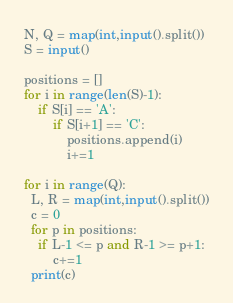<code> <loc_0><loc_0><loc_500><loc_500><_Python_>N, Q = map(int,input().split())
S = input()

positions = []
for i in range(len(S)-1):
    if S[i] == 'A':
        if S[i+1] == 'C':
            positions.append(i)
            i+=1

for i in range(Q):
  L, R = map(int,input().split())
  c = 0
  for p in positions:
    if L-1 <= p and R-1 >= p+1:
        c+=1
  print(c)
</code> 